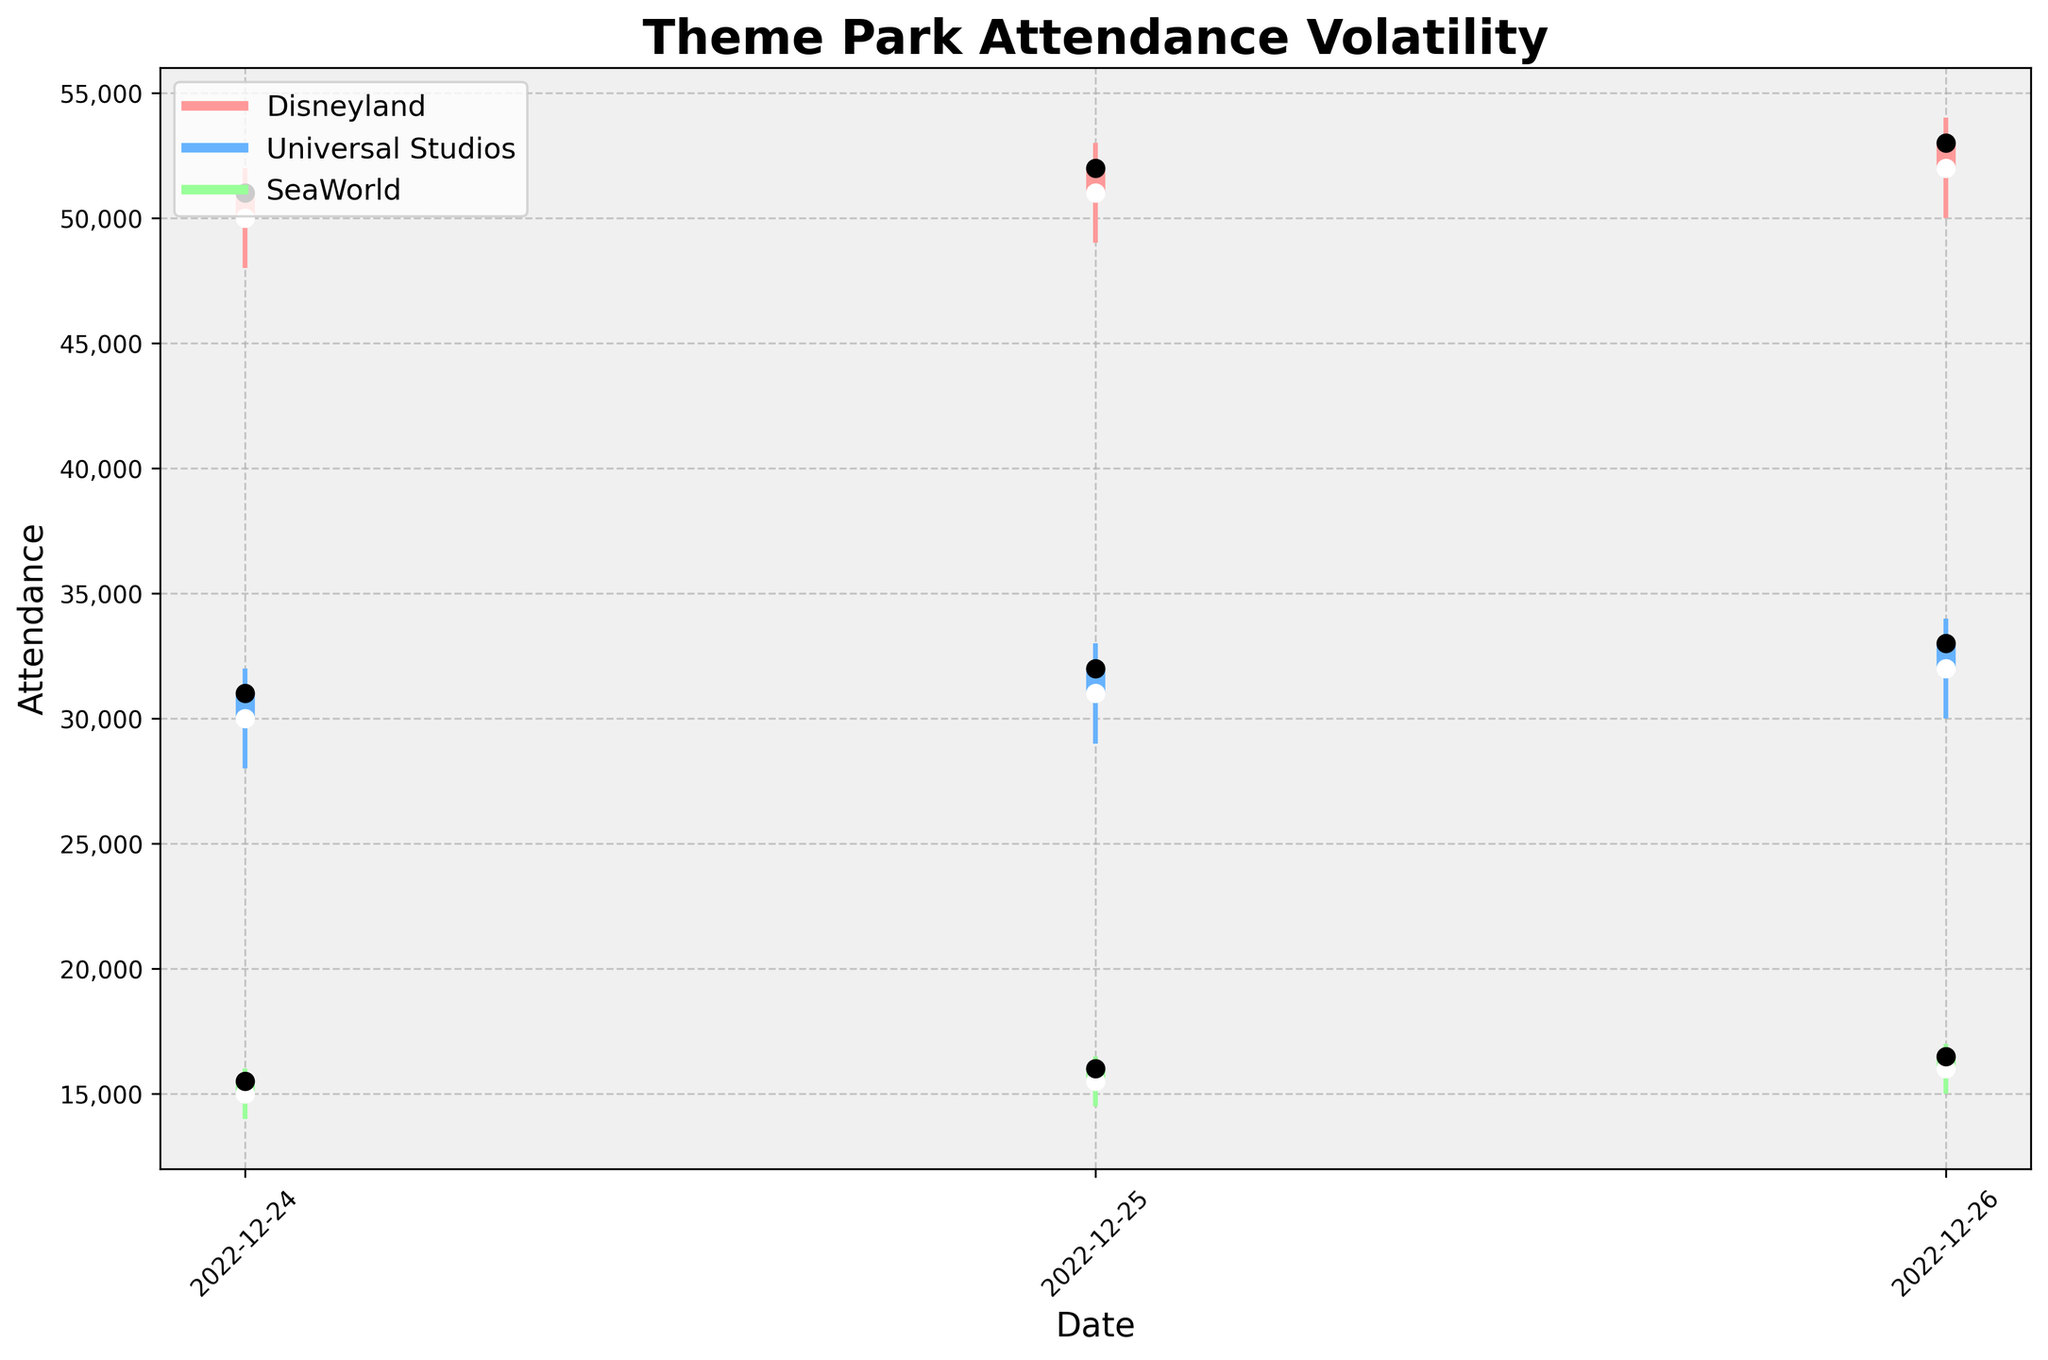What's the title of the plot? Look for the largest text at the top of the plot which represents the title.
Answer: Theme Park Attendance Volatility When was the highest attendance for Disneyland? Identify the highest point on the High line for Disneyland and observe its corresponding date on the x-axis. The highest value occurs on December 26, 2022, with an attendance of 54,000.
Answer: 2022-12-26 Which park had the lowest attendance on December 24, 2022? Compare the Low points for each park on December 24, 2022, and identify the smallest value. SeaWorld had the lowest with 14,000.
Answer: SeaWorld What was the closing attendance for Universal Studios on December 25, 2022? Look for the closing value (indicated by the end of the thicker vertical bar) for Universal Studios on the given date. It was 32,000.
Answer: 32,000 On which date did all three parks have the highest attendance fluctuations (range between High and Low)? Calculate the range for each park on each date and summarize them. December 26th has the highest fluctuation across all three parks.
Answer: 2022-12-26 What is the average daily closing attendance for SeaWorld? Sum the closing attendances for SeaWorld across all days and divide by the number of days (15,500 + 16,000 + 16,500) / 3.
Answer: 16,000 Which park had the most consistent (smallest range) attendance across the three holiday periods? Compare the range (High - Low) for each park across all dates and calculate their averages. SeaWorld consistently shows the smallest range.
Answer: SeaWorld Was there any day when the opening attendance was higher than the closing attendance for all parks? Check if the opening values were higher than the closing values for each park on any specific day. This was observed on no day across the dataset.
Answer: No How does the attendance of Universal Studios on December 26, 2022, compare to the attendance of Disneyland on December 24, 2022? Compare the closing attendances: Universal Studios on December 26 was 33,000 and Disneyland on December 24 was 51,000.
Answer: Lower What can you infer about holiday attendance trends from the plot? Examine overall attendance movement trends across the dates, observing the general increase in attendance closer to the more significant holidays (as seen for all parks).
Answer: Increasing closer to holidays 